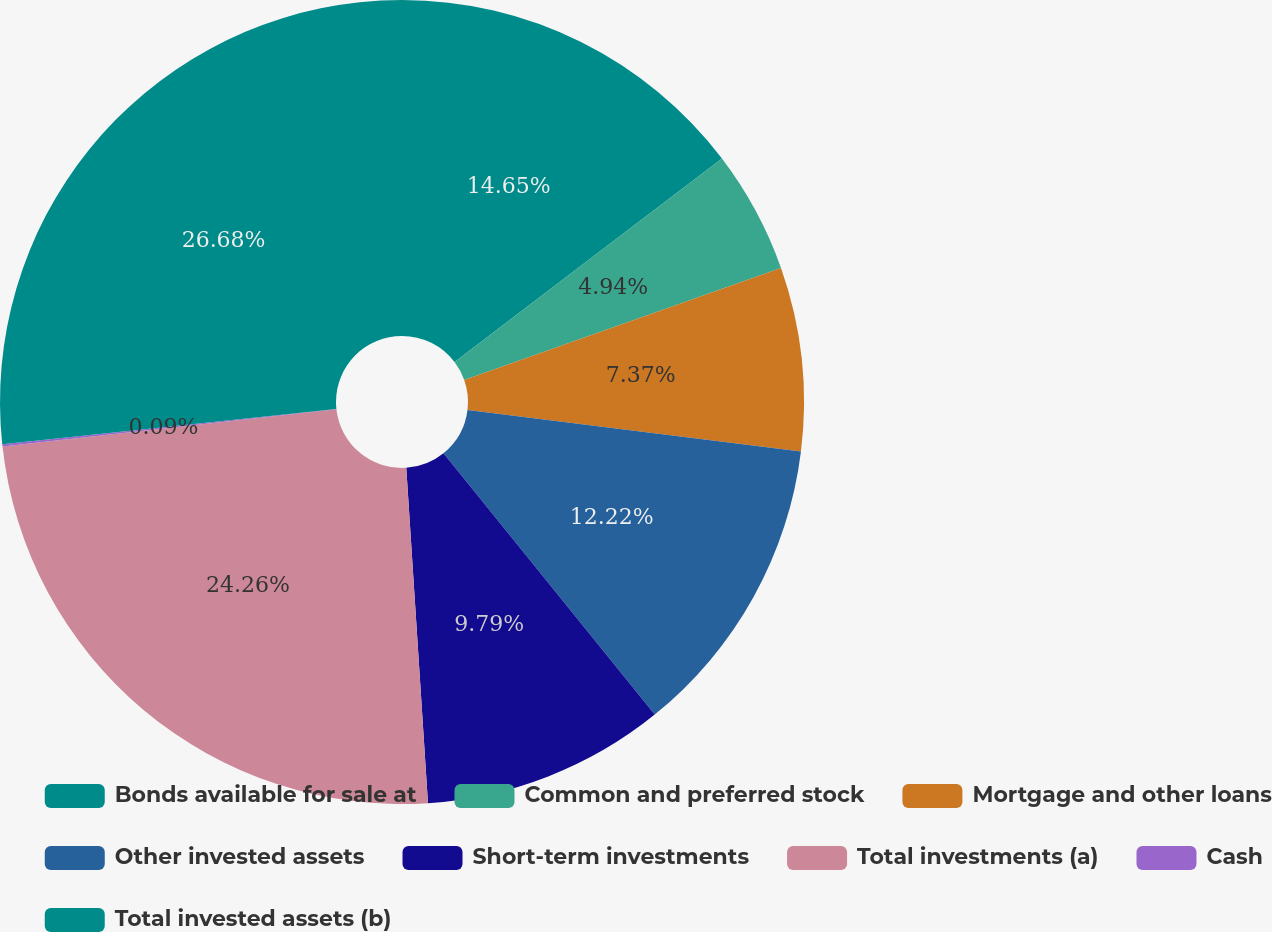Convert chart. <chart><loc_0><loc_0><loc_500><loc_500><pie_chart><fcel>Bonds available for sale at<fcel>Common and preferred stock<fcel>Mortgage and other loans<fcel>Other invested assets<fcel>Short-term investments<fcel>Total investments (a)<fcel>Cash<fcel>Total invested assets (b)<nl><fcel>14.65%<fcel>4.94%<fcel>7.37%<fcel>12.22%<fcel>9.79%<fcel>24.26%<fcel>0.09%<fcel>26.68%<nl></chart> 